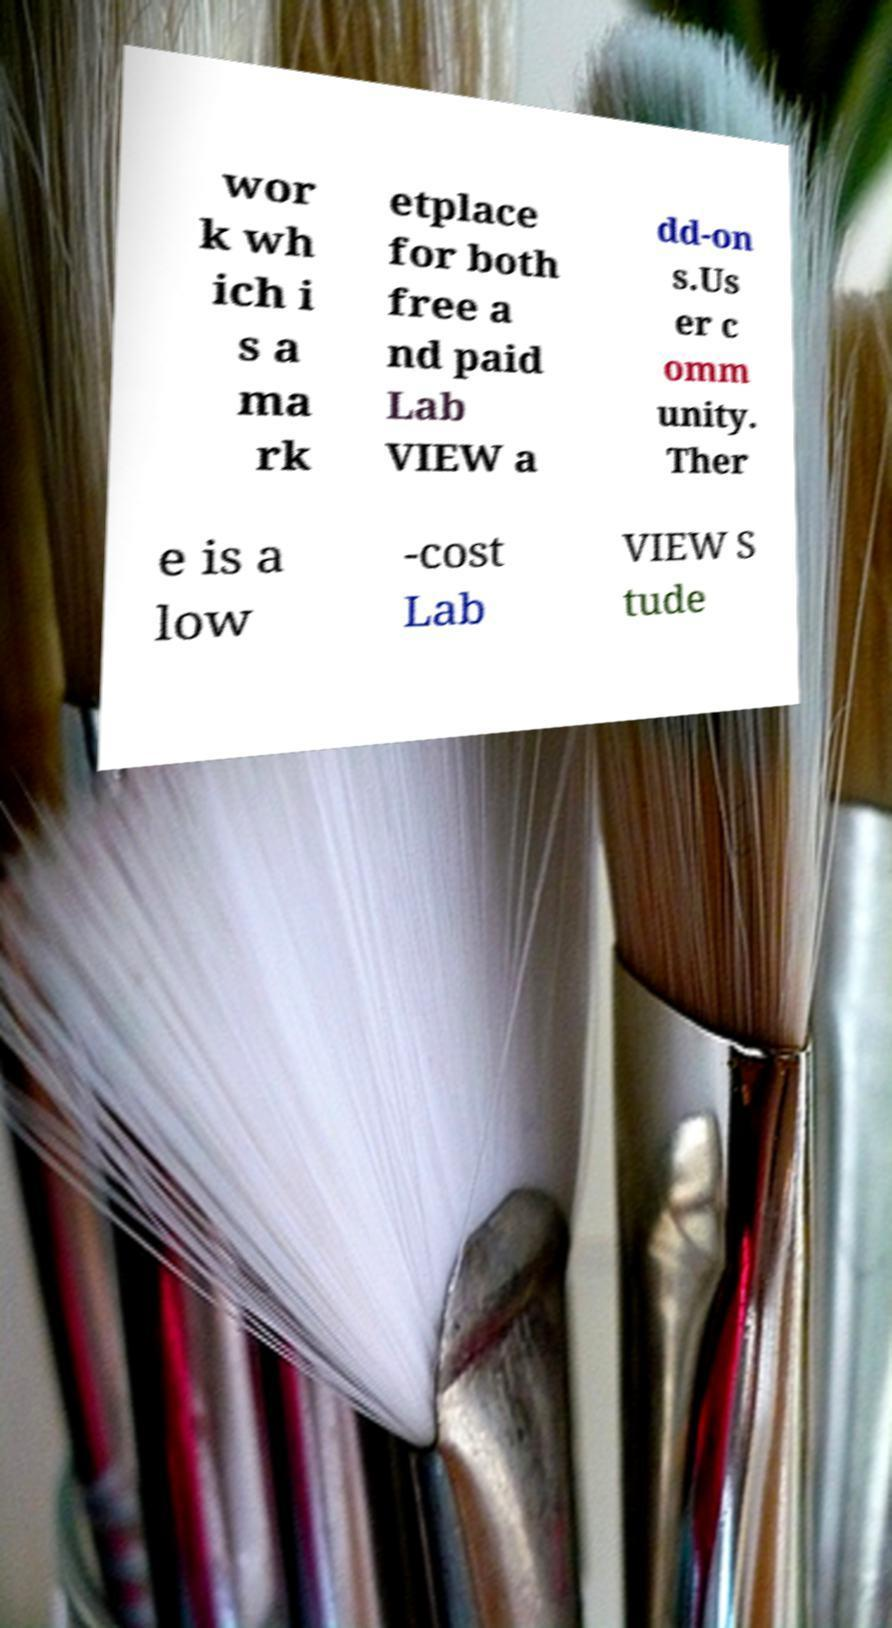Please read and relay the text visible in this image. What does it say? wor k wh ich i s a ma rk etplace for both free a nd paid Lab VIEW a dd-on s.Us er c omm unity. Ther e is a low -cost Lab VIEW S tude 